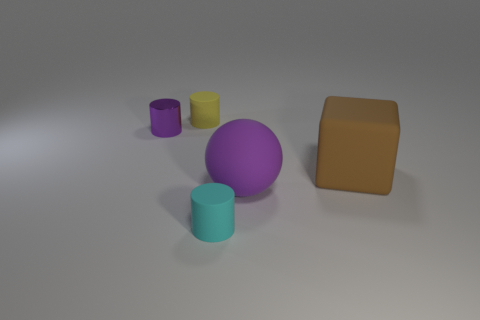Add 1 small brown cylinders. How many objects exist? 6 Subtract all spheres. How many objects are left? 4 Add 5 small cylinders. How many small cylinders are left? 8 Add 5 yellow rubber cylinders. How many yellow rubber cylinders exist? 6 Subtract 0 yellow blocks. How many objects are left? 5 Subtract all large purple matte things. Subtract all tiny cylinders. How many objects are left? 1 